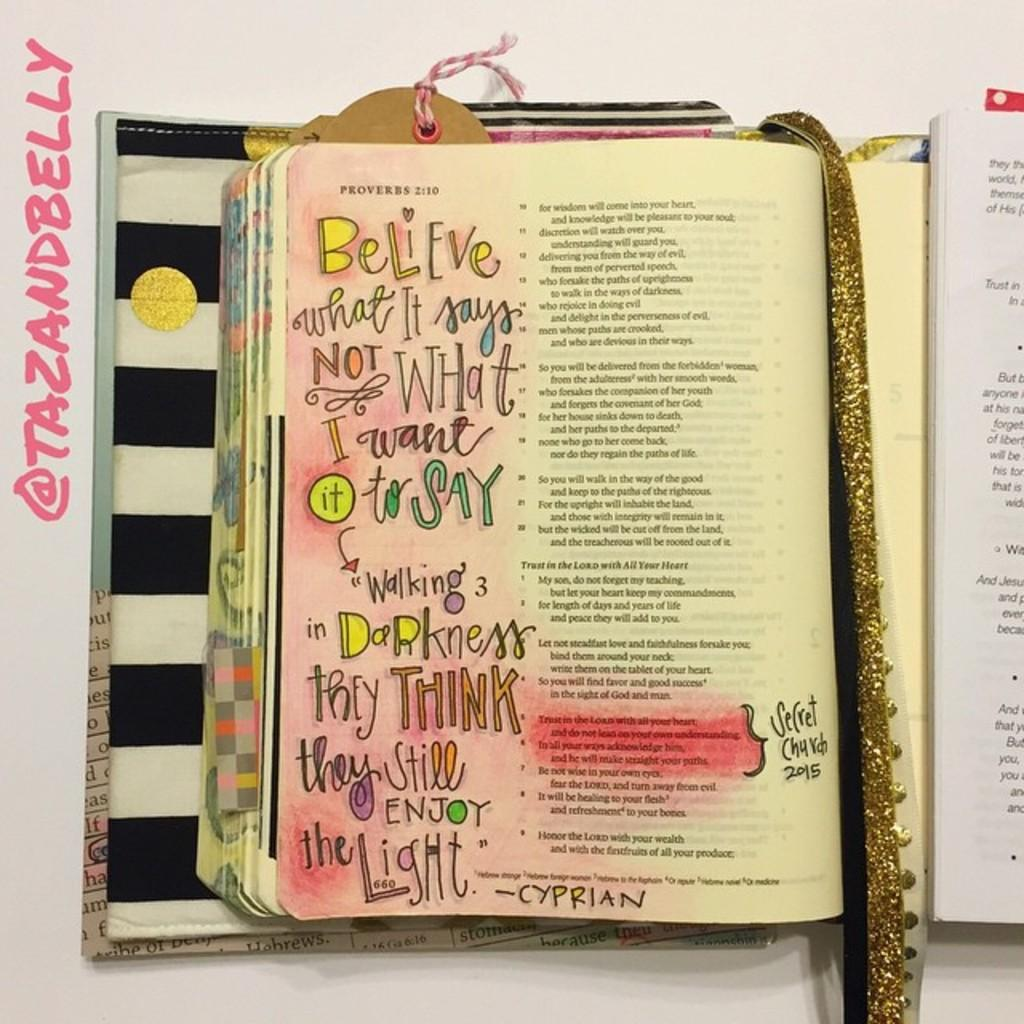<image>
Give a short and clear explanation of the subsequent image. Book open with a glitter gold ribbon in the middle that says believe. 